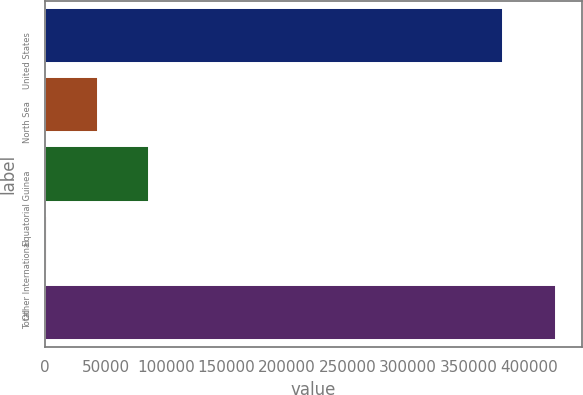Convert chart to OTSL. <chart><loc_0><loc_0><loc_500><loc_500><bar_chart><fcel>United States<fcel>North Sea<fcel>Equatorial Guinea<fcel>Other International<fcel>Total<nl><fcel>378475<fcel>43730.3<fcel>85809.6<fcel>1651<fcel>422444<nl></chart> 